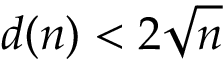<formula> <loc_0><loc_0><loc_500><loc_500>d ( n ) < 2 { \sqrt { n } }</formula> 